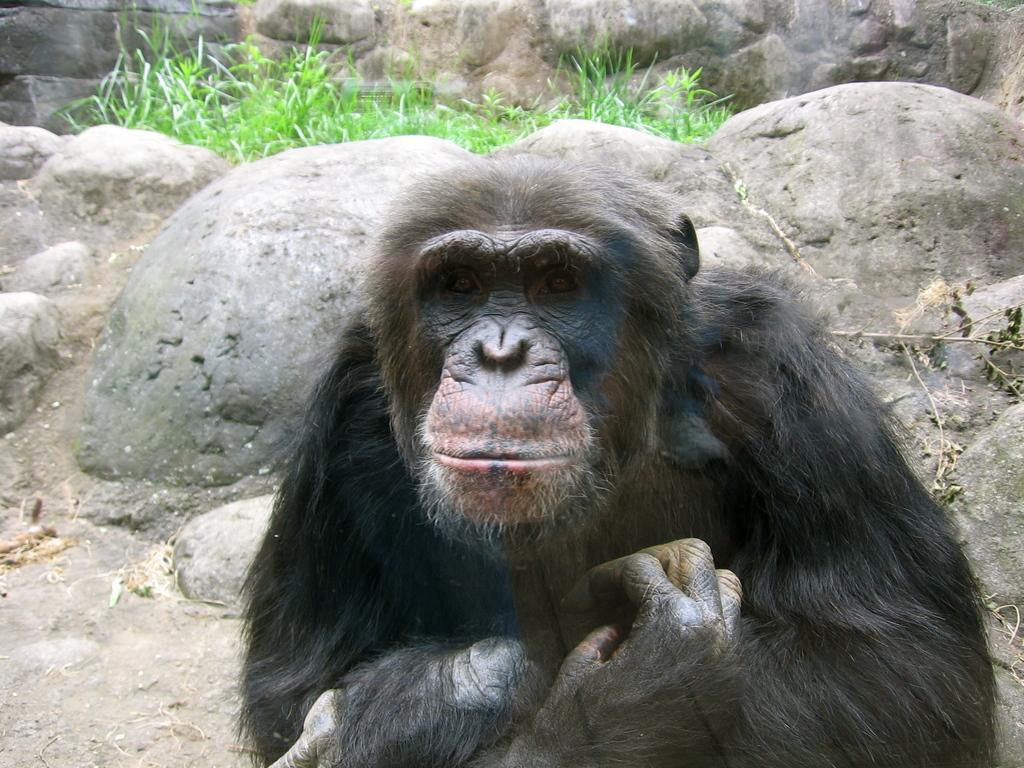Please provide a concise description of this image. In the center of the image we can see a chimpanzee. In the background of the image we can see rocks, grass are there. At the bottom of the image there is a ground. 